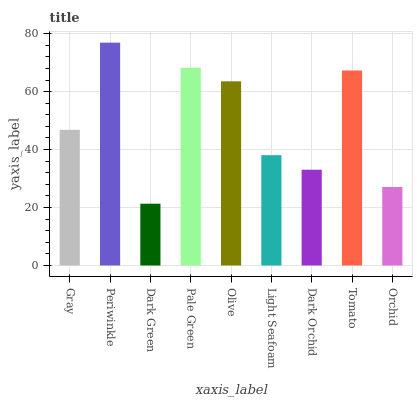Is Dark Green the minimum?
Answer yes or no. Yes. Is Periwinkle the maximum?
Answer yes or no. Yes. Is Periwinkle the minimum?
Answer yes or no. No. Is Dark Green the maximum?
Answer yes or no. No. Is Periwinkle greater than Dark Green?
Answer yes or no. Yes. Is Dark Green less than Periwinkle?
Answer yes or no. Yes. Is Dark Green greater than Periwinkle?
Answer yes or no. No. Is Periwinkle less than Dark Green?
Answer yes or no. No. Is Gray the high median?
Answer yes or no. Yes. Is Gray the low median?
Answer yes or no. Yes. Is Orchid the high median?
Answer yes or no. No. Is Olive the low median?
Answer yes or no. No. 